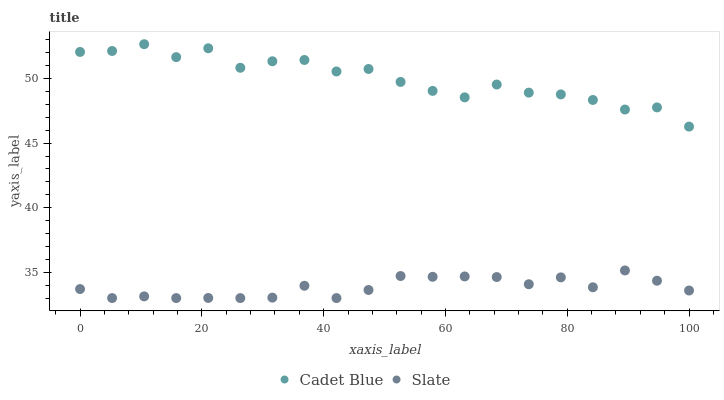Does Slate have the minimum area under the curve?
Answer yes or no. Yes. Does Cadet Blue have the maximum area under the curve?
Answer yes or no. Yes. Does Cadet Blue have the minimum area under the curve?
Answer yes or no. No. Is Slate the smoothest?
Answer yes or no. Yes. Is Cadet Blue the roughest?
Answer yes or no. Yes. Is Cadet Blue the smoothest?
Answer yes or no. No. Does Slate have the lowest value?
Answer yes or no. Yes. Does Cadet Blue have the lowest value?
Answer yes or no. No. Does Cadet Blue have the highest value?
Answer yes or no. Yes. Is Slate less than Cadet Blue?
Answer yes or no. Yes. Is Cadet Blue greater than Slate?
Answer yes or no. Yes. Does Slate intersect Cadet Blue?
Answer yes or no. No. 